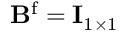<formula> <loc_0><loc_0><loc_500><loc_500>B ^ { f } = I _ { 1 \times 1 }</formula> 